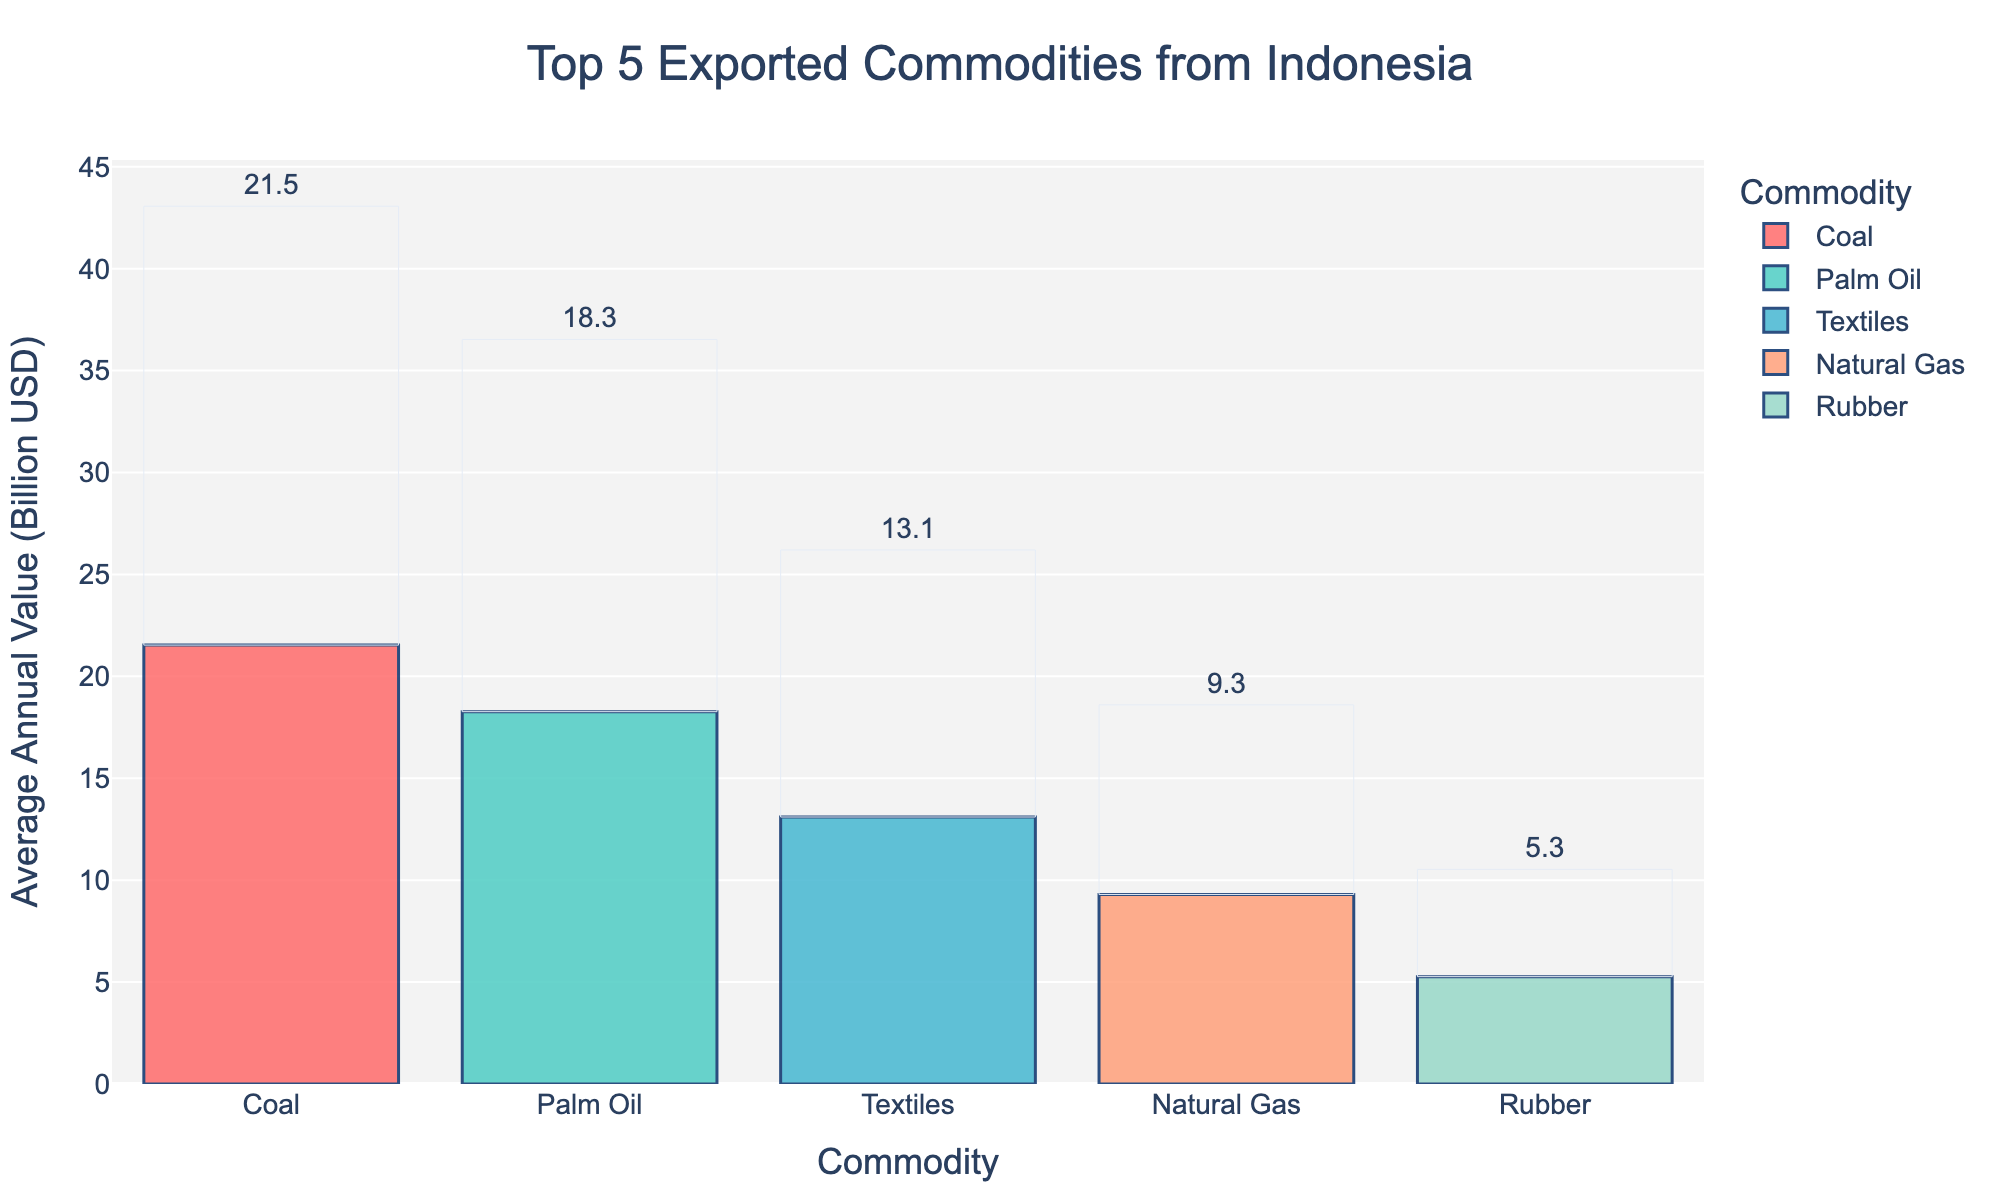What is the most exported commodity from Indonesia in terms of average annual value? The bar chart shows the average annual values for each commodity. Coal has the highest bar, indicating it is the most exported commodity.
Answer: Coal Which commodity has the lowest average annual value in the figure? The bar for Rubber is the shortest, showing that it has the lowest average annual value among the top 5 commodities.
Answer: Rubber How much higher is the average annual value of Coal compared to Natural Gas? The average annual value for Coal is 21.5 and for Natural Gas it is 9.3. The difference is 21.5 - 9.3 = 12.2 billion USD.
Answer: 12.2 billion USD What is the combined average annual value of Palm Oil and Textiles exports? The average annual values are 18.2 for Palm Oil and 13.1 for Textiles. Adding them gives 18.2 + 13.1 = 31.3 billion USD.
Answer: 31.3 billion USD Which commodities have an average annual value greater than 10 billion USD? The commodities with bars extending beyond the 10 billion USD mark are Palm Oil, Coal, and Textiles.
Answer: Palm Oil, Coal, Textiles How does the average annual value of Rubber compare to Natural Gas? The average annual value of Rubber is lower than Natural Gas. Rubber is 5.2 billion USD, while Natural Gas is 9.3 billion USD.
Answer: Rubber is lower How many commodities have an average annual value between 5 billion USD and 10 billion USD? The bars representing Natural Gas and Rubber fall within the 5 to 10 billion USD range. So, there are 2 commodities.
Answer: 2 What is the average annual value of Coal exports? The bar for Coal shows an average annual value of 21.5 billion USD, which is the highest among the displayed commodities.
Answer: 21.5 billion USD What is the total average annual export value of all commodities shown? Summing the average annual values of all commodities: 18.2 (Palm Oil) + 21.5 (Coal) + 9.3 (Natural Gas) + 5.2 (Rubber) + 13.1 (Textiles) = 67.3 billion USD.
Answer: 67.3 billion USD 